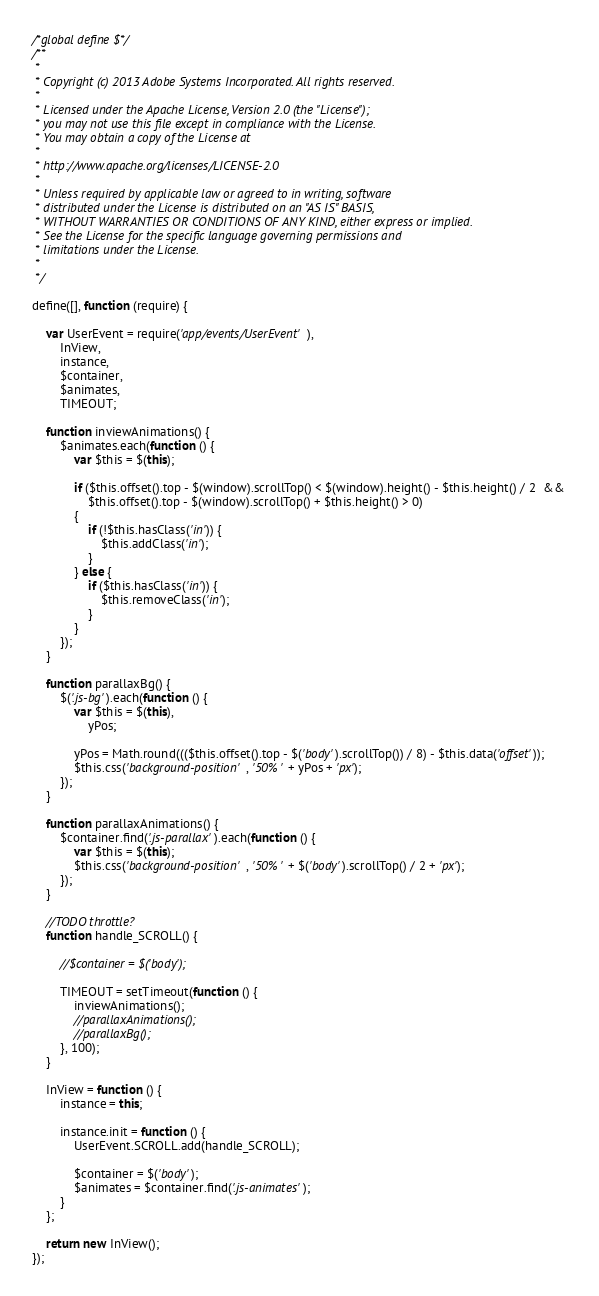<code> <loc_0><loc_0><loc_500><loc_500><_JavaScript_>/*global define $*/
/**
 *
 * Copyright (c) 2013 Adobe Systems Incorporated. All rights reserved.
 *
 * Licensed under the Apache License, Version 2.0 (the "License");
 * you may not use this file except in compliance with the License.
 * You may obtain a copy of the License at
 * 
 * http://www.apache.org/licenses/LICENSE-2.0
 *
 * Unless required by applicable law or agreed to in writing, software
 * distributed under the License is distributed on an "AS IS" BASIS,
 * WITHOUT WARRANTIES OR CONDITIONS OF ANY KIND, either express or implied.
 * See the License for the specific language governing permissions and
 * limitations under the License.
 *
 */

define([], function (require) {

    var UserEvent = require('app/events/UserEvent'),
        InView,
        instance,
        $container,
        $animates,
        TIMEOUT;

    function inviewAnimations() {
        $animates.each(function () {
            var $this = $(this);

            if ($this.offset().top - $(window).scrollTop() < $(window).height() - $this.height() / 2  && 
				$this.offset().top - $(window).scrollTop() + $this.height() > 0) 
            {
                if (!$this.hasClass('in')) {
                    $this.addClass('in');
                }
            } else {
                if ($this.hasClass('in')) {
                    $this.removeClass('in');
                }
            }
        });
    }

	function parallaxBg() {
		$('.js-bg').each(function () {
            var $this = $(this),
                yPos;

			yPos = Math.round((($this.offset().top - $('body').scrollTop()) / 8) - $this.data('offset'));
            $this.css('background-position', '50% ' + yPos + 'px');
        });
	}

    function parallaxAnimations() {
        $container.find('.js-parallax').each(function () {
            var $this = $(this);
            $this.css('background-position', '50% ' + $('body').scrollTop() / 2 + 'px');
        });
    }

    //TODO throttle?
    function handle_SCROLL() {

        //$container = $('body');
        
        TIMEOUT = setTimeout(function () {
            inviewAnimations();
            //parallaxAnimations();
            //parallaxBg();
        }, 100);
    }

    InView = function () {
        instance = this;

        instance.init = function () {
            UserEvent.SCROLL.add(handle_SCROLL);
        
            $container = $('body');
            $animates = $container.find('.js-animates');
        }
    };

    return new InView();
});
</code> 